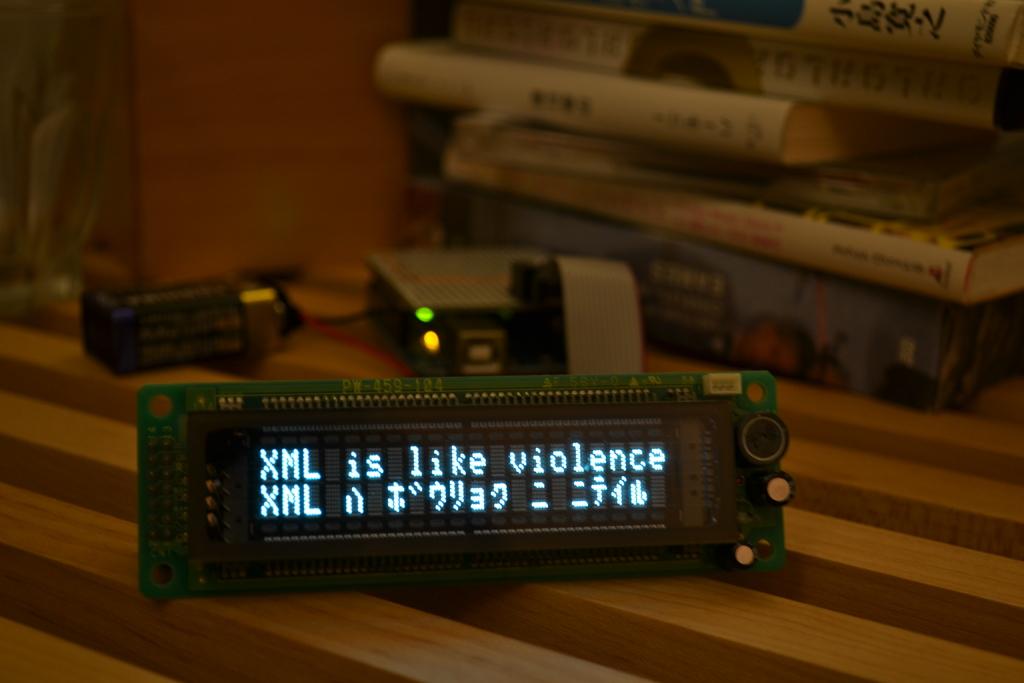How many books are stacked?
Ensure brevity in your answer.  Answering does not require reading text in the image. What is displayed in the top line of this display panel?
Ensure brevity in your answer.  Xml is like violence. 